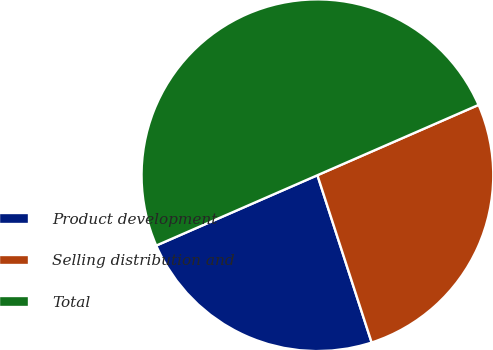<chart> <loc_0><loc_0><loc_500><loc_500><pie_chart><fcel>Product development<fcel>Selling distribution and<fcel>Total<nl><fcel>23.44%<fcel>26.56%<fcel>50.0%<nl></chart> 